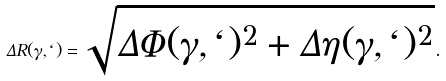Convert formula to latex. <formula><loc_0><loc_0><loc_500><loc_500>\Delta R ( \gamma , \ell ) = \sqrt { \Delta \Phi ( \gamma , \ell ) ^ { 2 } + \Delta \eta ( \gamma , \ell ) ^ { 2 } } .</formula> 